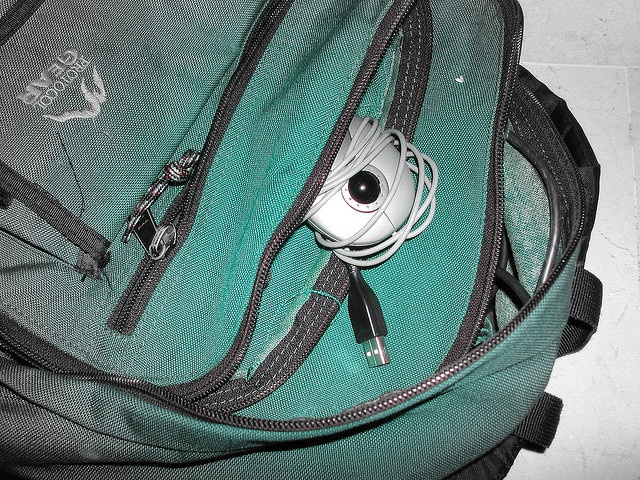Describe the objects in this image and their specific colors. I can see backpack in darkgray, black, gray, and teal tones and mouse in darkgray, lightgray, black, and gray tones in this image. 